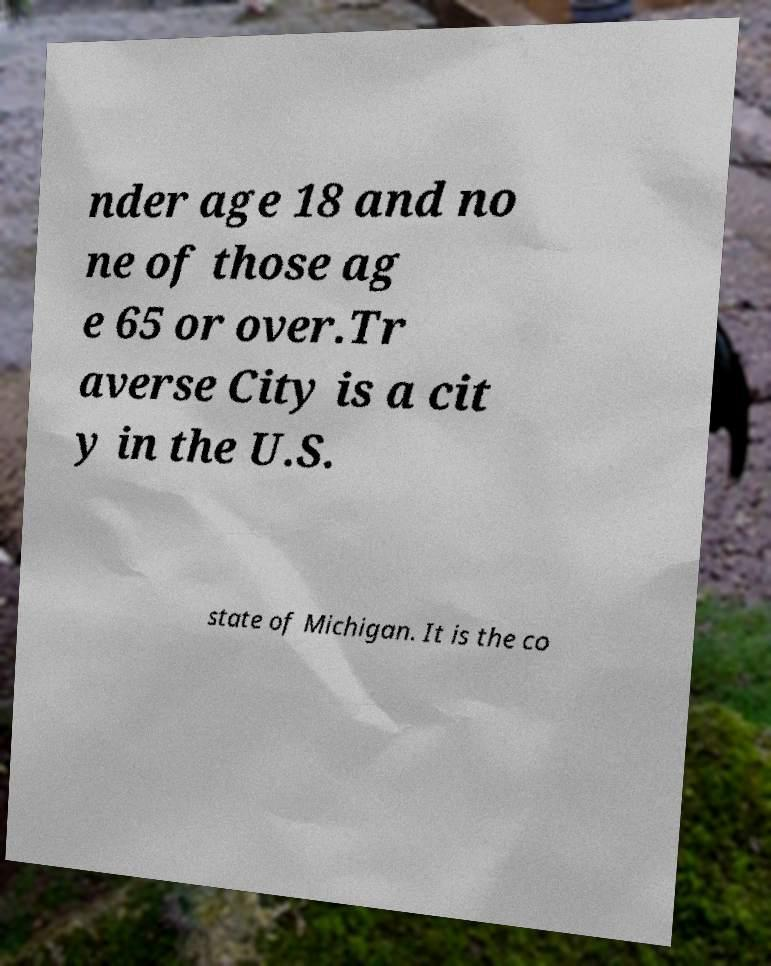Could you assist in decoding the text presented in this image and type it out clearly? nder age 18 and no ne of those ag e 65 or over.Tr averse City is a cit y in the U.S. state of Michigan. It is the co 